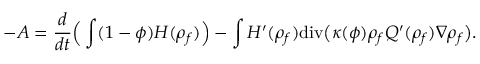<formula> <loc_0><loc_0><loc_500><loc_500>- A = \frac { d } { d t } \left ( \int ( 1 - \phi ) { H } ( { \rho } _ { f } ) \right ) - \int { H } ^ { \prime } ( { \rho } _ { f } ) d i v \left ( \kappa ( \phi ) { \rho } _ { f } { Q } ^ { \prime } ( { \rho } _ { f } ) \nabla { \rho } _ { f } \right ) .</formula> 